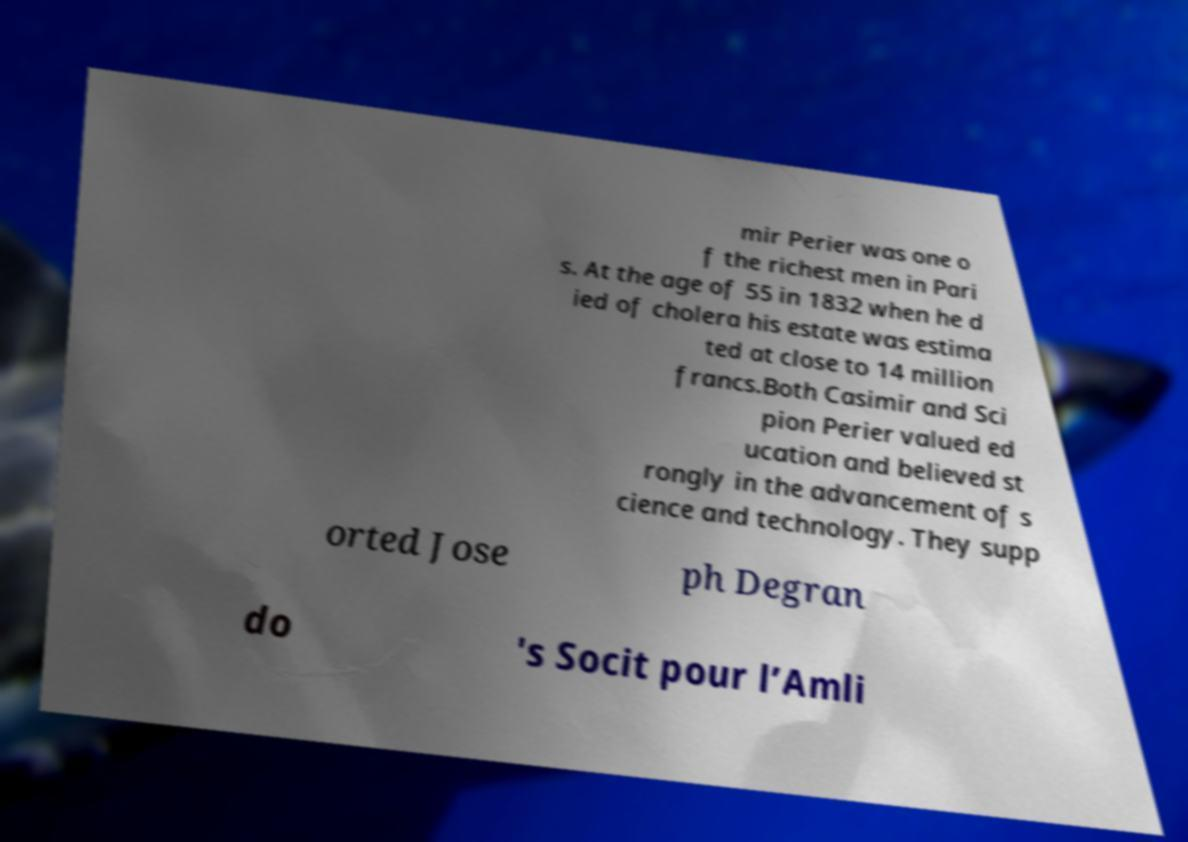Could you assist in decoding the text presented in this image and type it out clearly? mir Perier was one o f the richest men in Pari s. At the age of 55 in 1832 when he d ied of cholera his estate was estima ted at close to 14 million francs.Both Casimir and Sci pion Perier valued ed ucation and believed st rongly in the advancement of s cience and technology. They supp orted Jose ph Degran do 's Socit pour l’Amli 